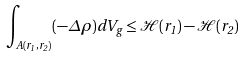Convert formula to latex. <formula><loc_0><loc_0><loc_500><loc_500>\int _ { A ( r _ { 1 } , r _ { 2 } ) } ( - \Delta \rho ) d V _ { g } \leq \mathcal { H } ( r _ { 1 } ) - \mathcal { H } ( r _ { 2 } )</formula> 